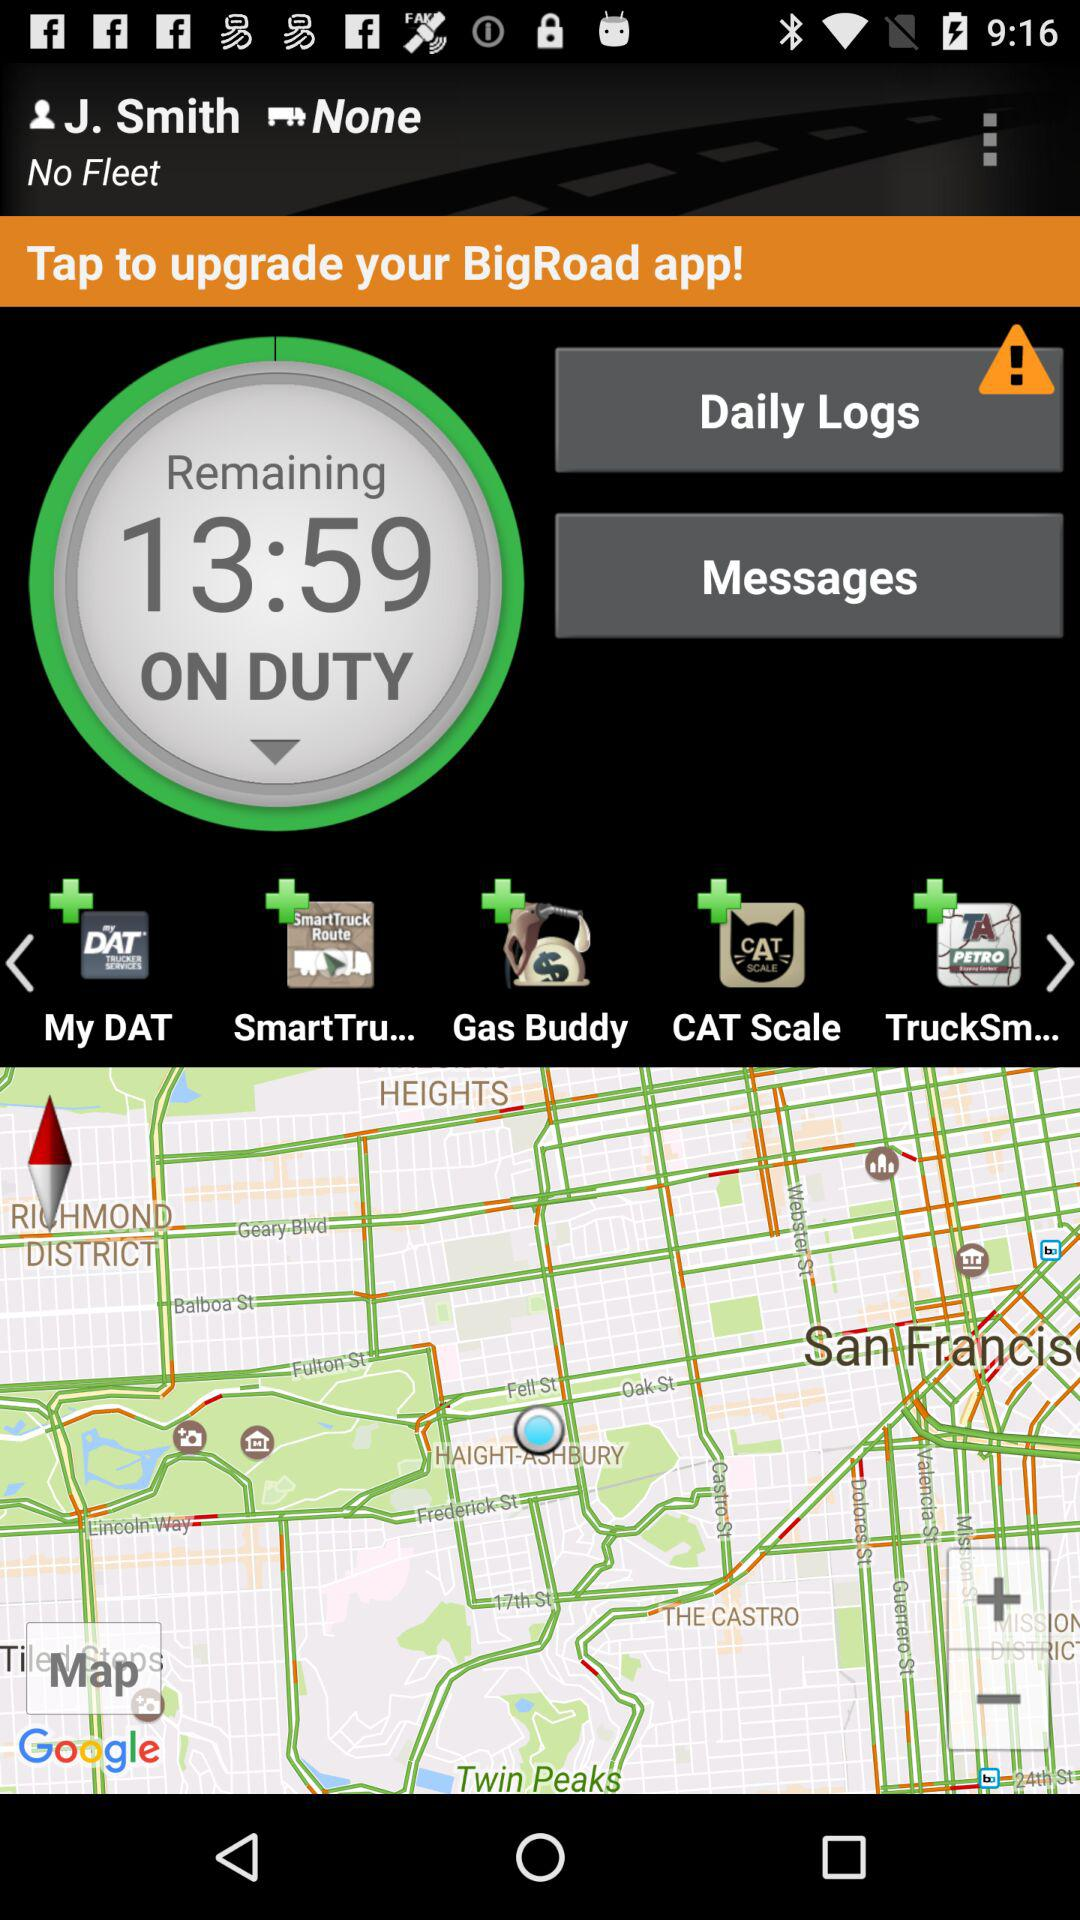How many unread messages are there?
When the provided information is insufficient, respond with <no answer>. <no answer> 